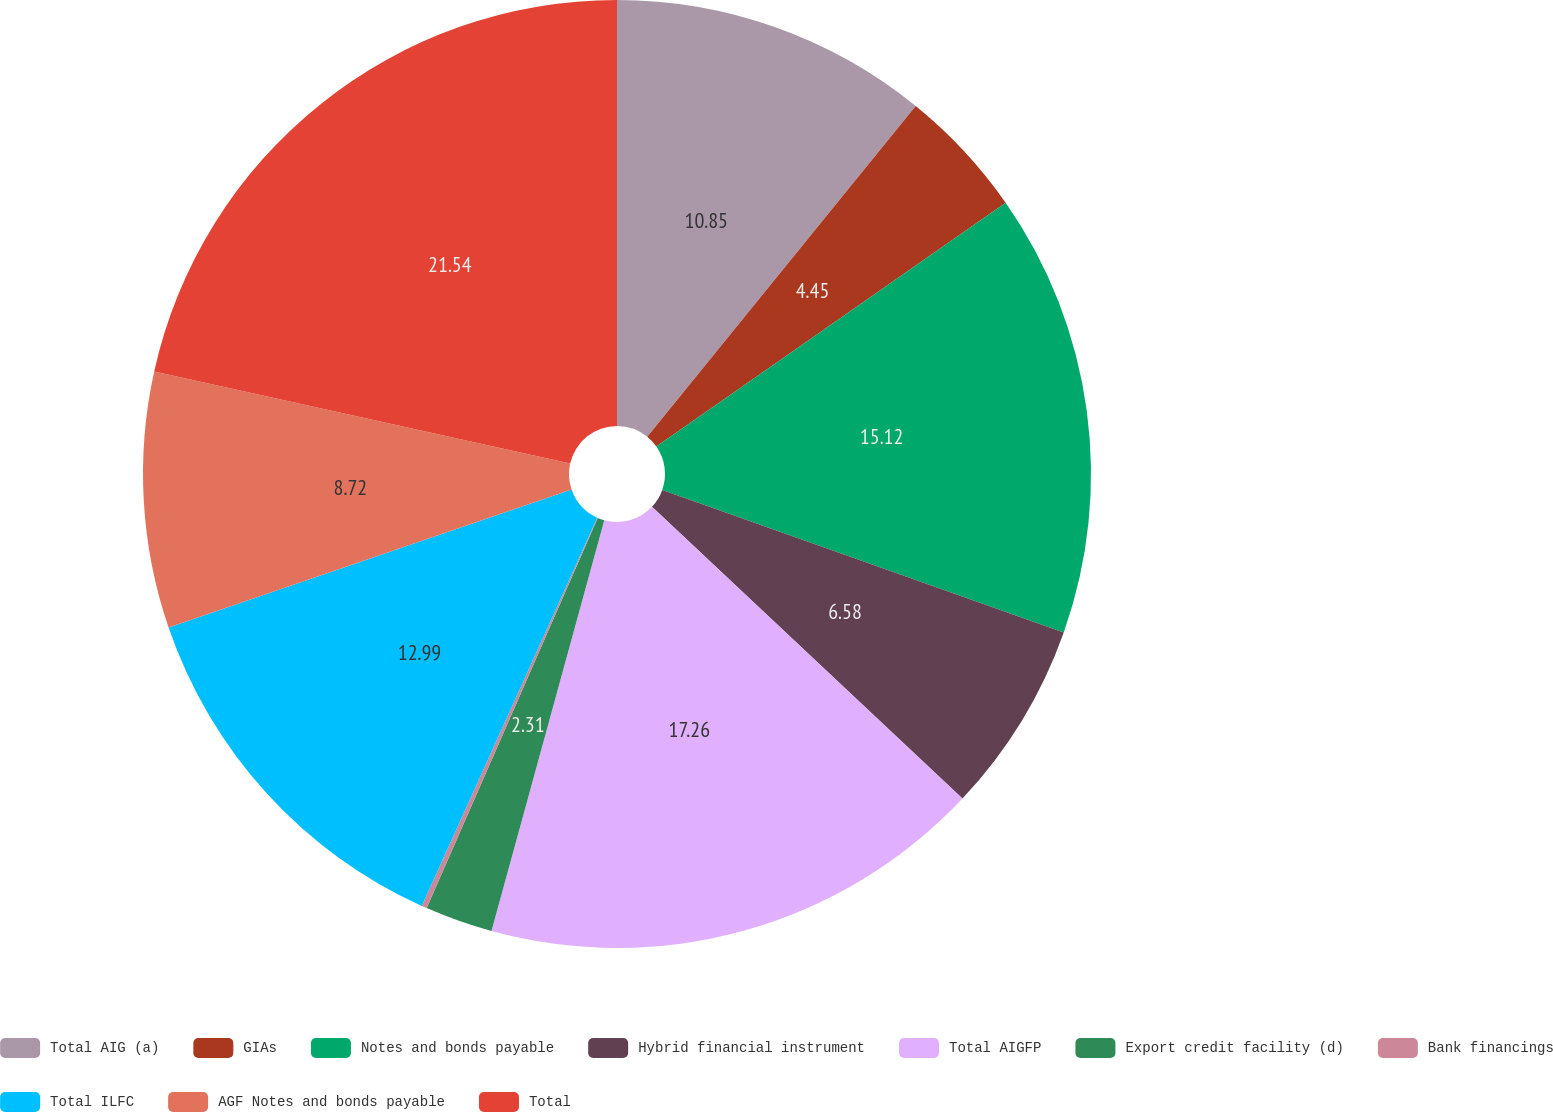Convert chart to OTSL. <chart><loc_0><loc_0><loc_500><loc_500><pie_chart><fcel>Total AIG (a)<fcel>GIAs<fcel>Notes and bonds payable<fcel>Hybrid financial instrument<fcel>Total AIGFP<fcel>Export credit facility (d)<fcel>Bank financings<fcel>Total ILFC<fcel>AGF Notes and bonds payable<fcel>Total<nl><fcel>10.85%<fcel>4.45%<fcel>15.12%<fcel>6.58%<fcel>17.26%<fcel>2.31%<fcel>0.18%<fcel>12.99%<fcel>8.72%<fcel>21.53%<nl></chart> 